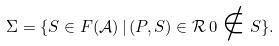Convert formula to latex. <formula><loc_0><loc_0><loc_500><loc_500>\Sigma = \{ S \in F ( \mathcal { A } ) \, | \, ( P , S ) \in \mathcal { R } \, 0 \notin S \} .</formula> 